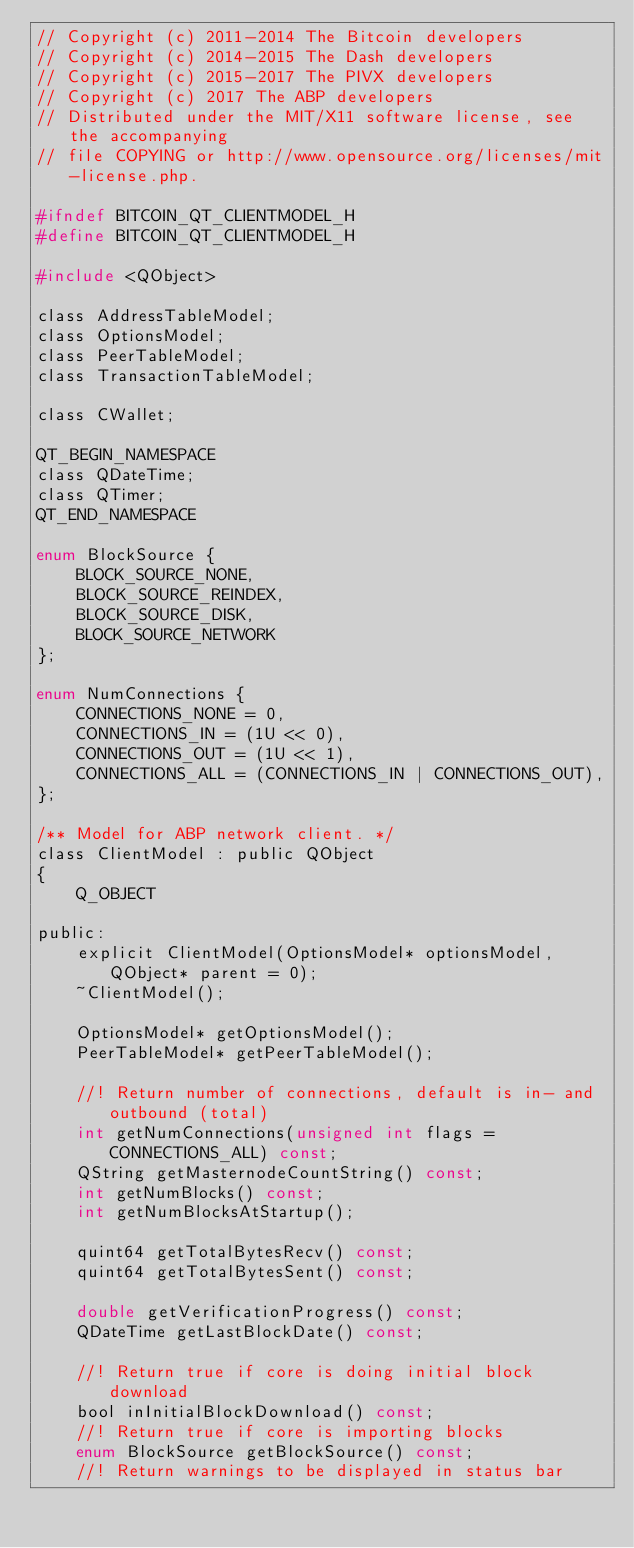Convert code to text. <code><loc_0><loc_0><loc_500><loc_500><_C_>// Copyright (c) 2011-2014 The Bitcoin developers
// Copyright (c) 2014-2015 The Dash developers
// Copyright (c) 2015-2017 The PIVX developers
// Copyright (c) 2017 The ABP developers
// Distributed under the MIT/X11 software license, see the accompanying
// file COPYING or http://www.opensource.org/licenses/mit-license.php.

#ifndef BITCOIN_QT_CLIENTMODEL_H
#define BITCOIN_QT_CLIENTMODEL_H

#include <QObject>

class AddressTableModel;
class OptionsModel;
class PeerTableModel;
class TransactionTableModel;

class CWallet;

QT_BEGIN_NAMESPACE
class QDateTime;
class QTimer;
QT_END_NAMESPACE

enum BlockSource {
    BLOCK_SOURCE_NONE,
    BLOCK_SOURCE_REINDEX,
    BLOCK_SOURCE_DISK,
    BLOCK_SOURCE_NETWORK
};

enum NumConnections {
    CONNECTIONS_NONE = 0,
    CONNECTIONS_IN = (1U << 0),
    CONNECTIONS_OUT = (1U << 1),
    CONNECTIONS_ALL = (CONNECTIONS_IN | CONNECTIONS_OUT),
};

/** Model for ABP network client. */
class ClientModel : public QObject
{
    Q_OBJECT

public:
    explicit ClientModel(OptionsModel* optionsModel, QObject* parent = 0);
    ~ClientModel();

    OptionsModel* getOptionsModel();
    PeerTableModel* getPeerTableModel();

    //! Return number of connections, default is in- and outbound (total)
    int getNumConnections(unsigned int flags = CONNECTIONS_ALL) const;
    QString getMasternodeCountString() const;
    int getNumBlocks() const;
    int getNumBlocksAtStartup();

    quint64 getTotalBytesRecv() const;
    quint64 getTotalBytesSent() const;

    double getVerificationProgress() const;
    QDateTime getLastBlockDate() const;

    //! Return true if core is doing initial block download
    bool inInitialBlockDownload() const;
    //! Return true if core is importing blocks
    enum BlockSource getBlockSource() const;
    //! Return warnings to be displayed in status bar</code> 